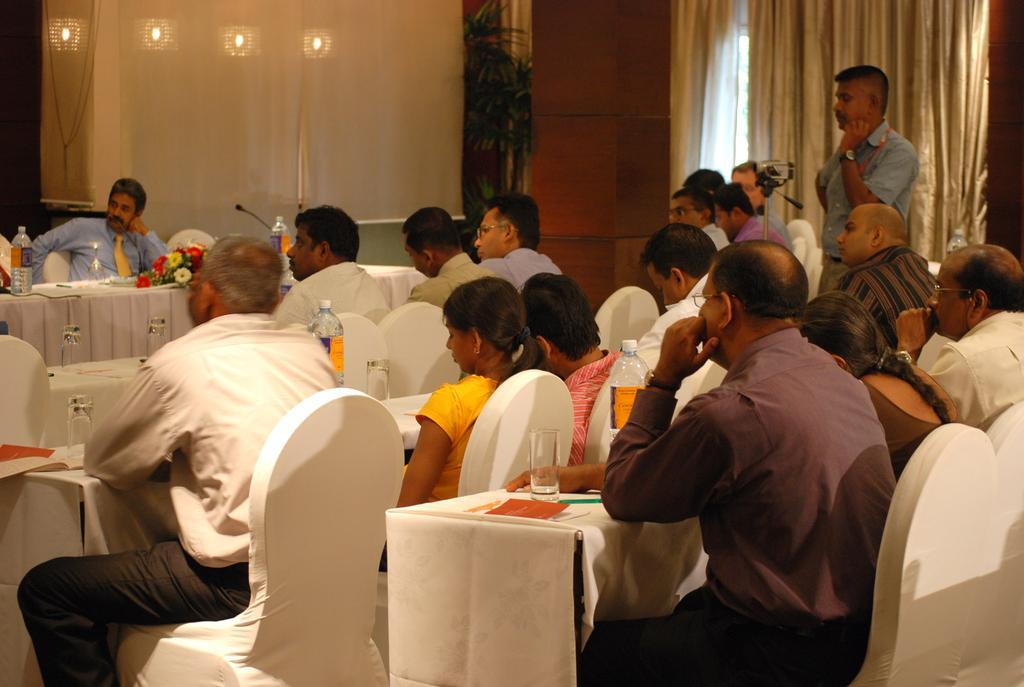Could you give a brief overview of what you see in this image? In this picture the group of people are sitting on chair. The man at the right side is standing. There are curtains in the background with 4 four spotlights, plant. At the right side there is a wall. On the table there are glasses, bottles, flowers and book. 